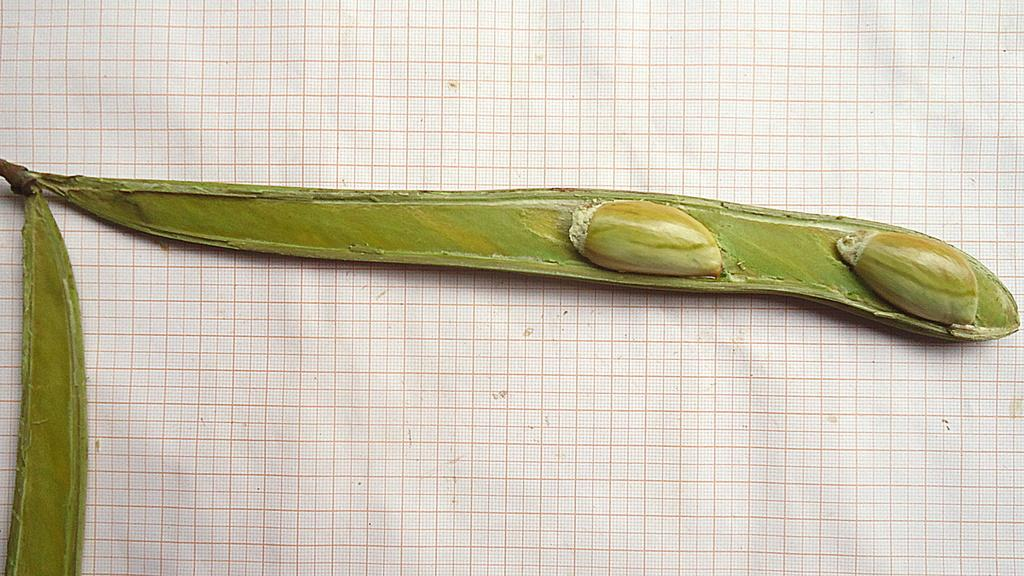What type of food is present in the image? There are beans in the image. What color are the beans? The beans are green in color. What can be seen in the background of the image? There is a cloth or sheet in the background of the image. What color is the cloth or sheet? The cloth or sheet is white in color. Can you see any worms crawling on the beans in the image? There are no worms present in the image; it only features beans and a white cloth or sheet in the background. 